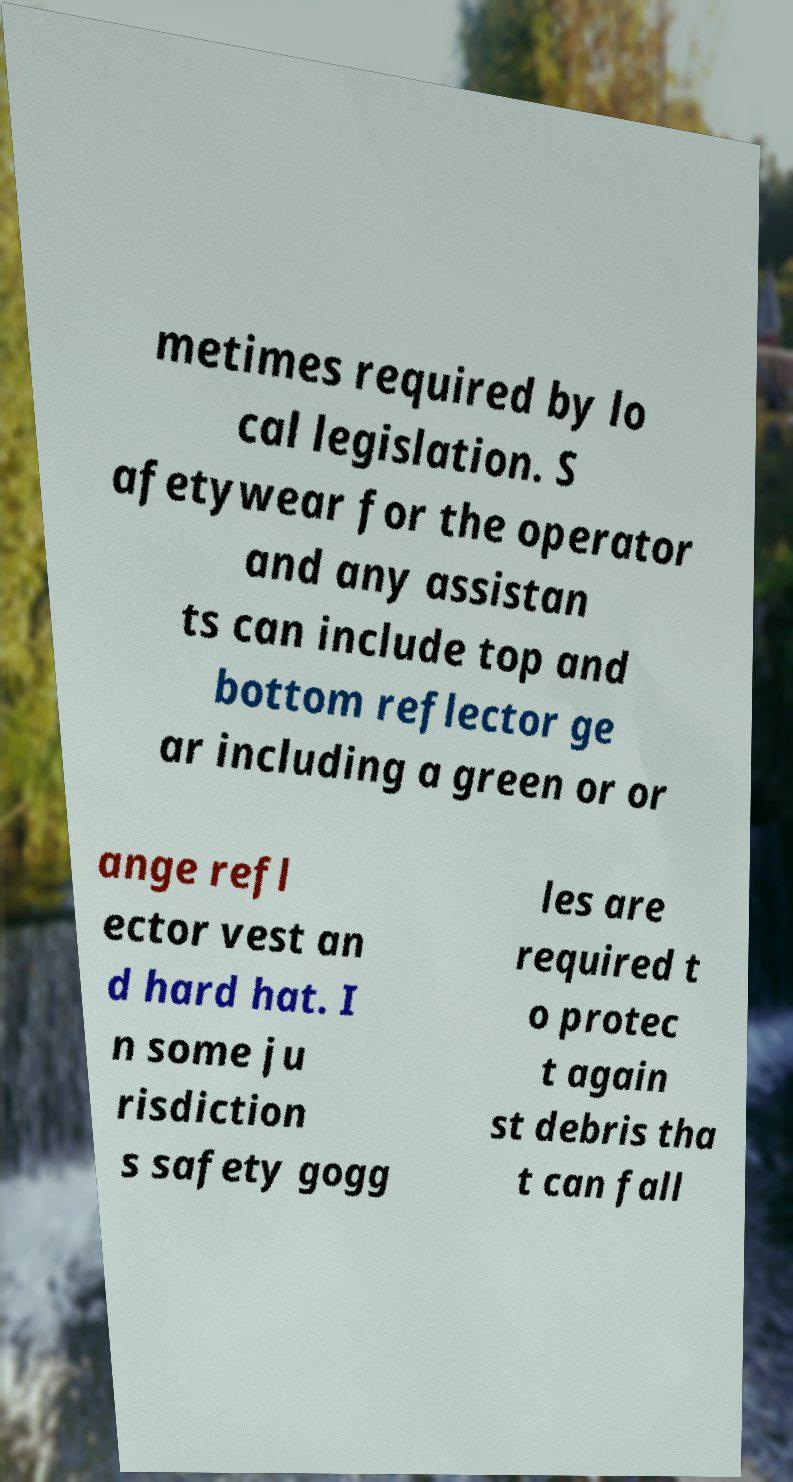I need the written content from this picture converted into text. Can you do that? metimes required by lo cal legislation. S afetywear for the operator and any assistan ts can include top and bottom reflector ge ar including a green or or ange refl ector vest an d hard hat. I n some ju risdiction s safety gogg les are required t o protec t again st debris tha t can fall 